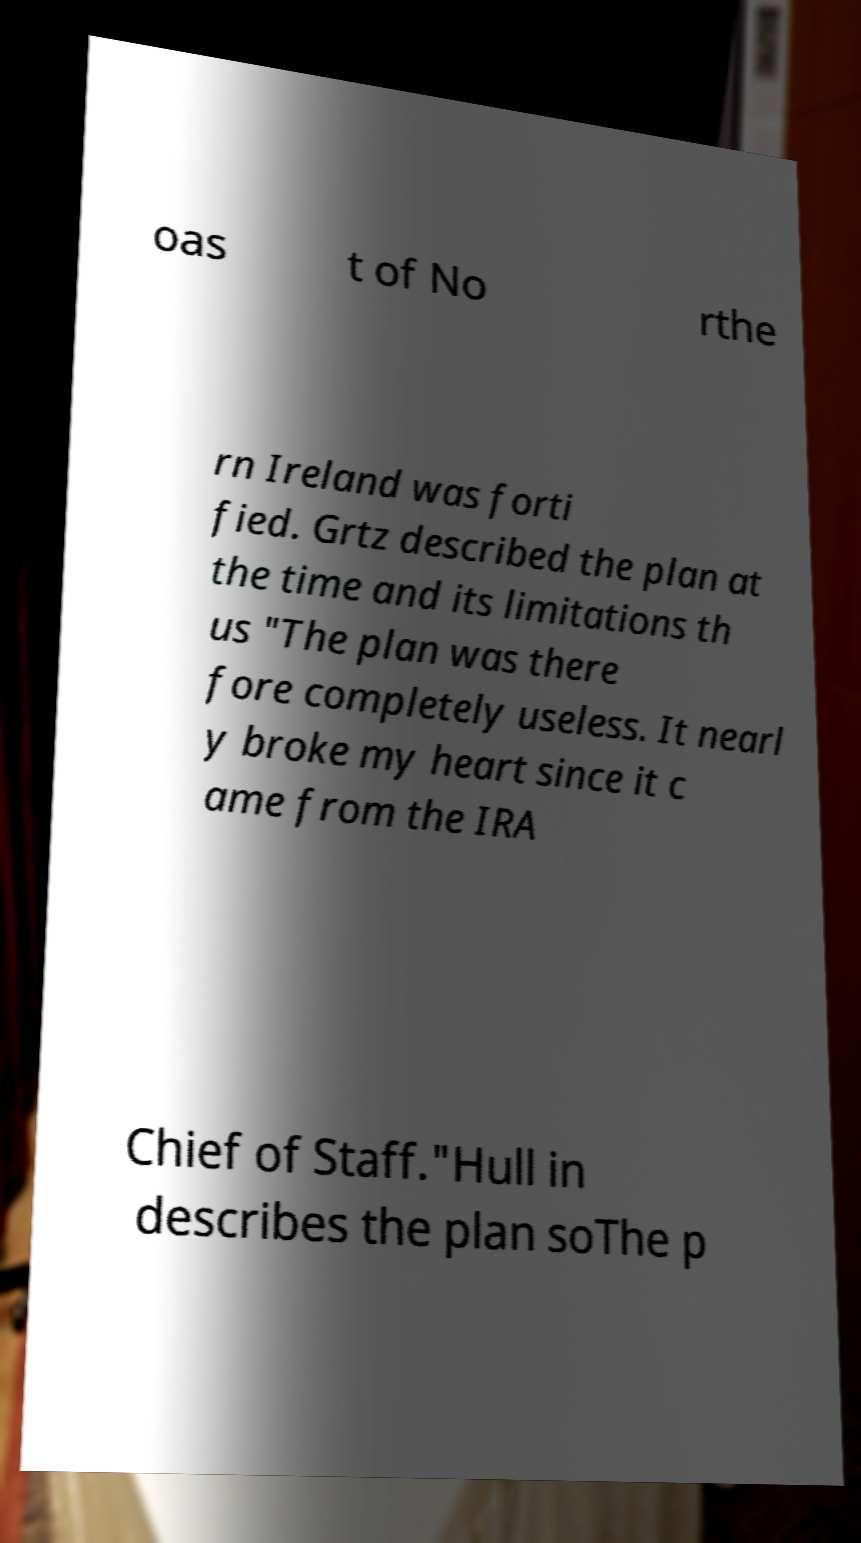For documentation purposes, I need the text within this image transcribed. Could you provide that? oas t of No rthe rn Ireland was forti fied. Grtz described the plan at the time and its limitations th us "The plan was there fore completely useless. It nearl y broke my heart since it c ame from the IRA Chief of Staff."Hull in describes the plan soThe p 